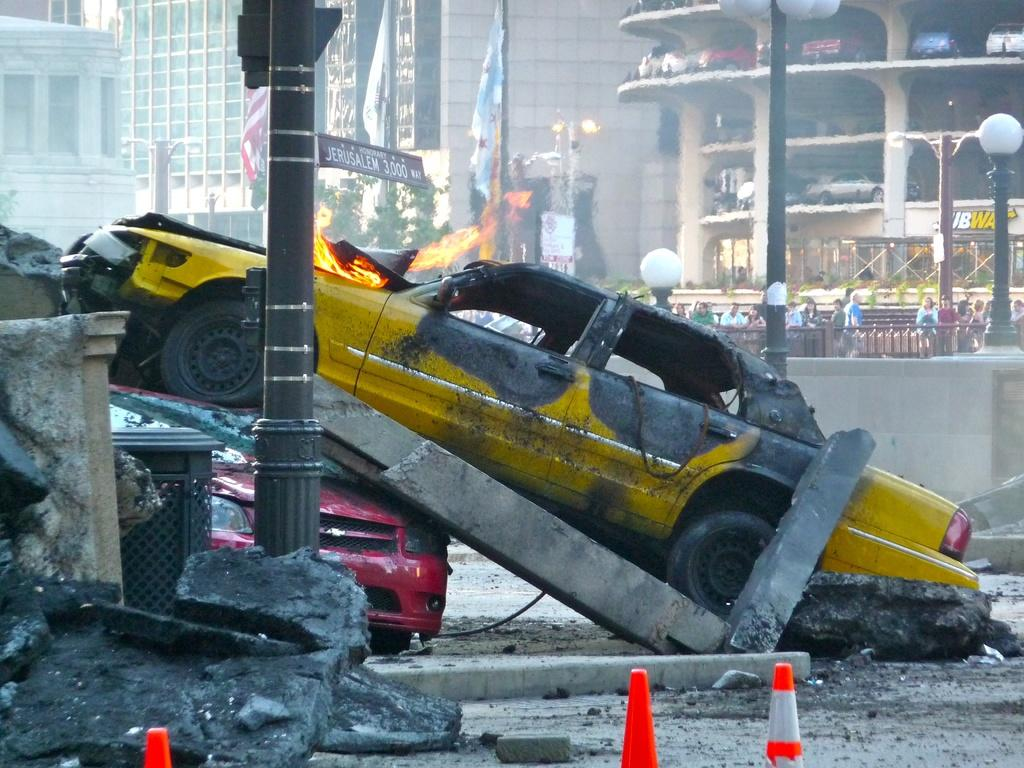What can be seen in the image that indicates a possible accident or incident? There are two damaged vehicles in the image, one of which has fire. What objects are present in the image that might be used to control traffic or guide people? There are traffic cones on the ground and flags in the image. What type of structures are visible in the background of the image? There are buildings in the image. What other objects can be seen in the image that are related to infrastructure or public spaces? There are pillars, light poles, and traffic cones in the image. What type of music is being played in the background of the image? There is no indication of music being played in the image. What language is being spoken by the people in the image? There are no people visible in the image, so it is impossible to determine the language being spoken. 